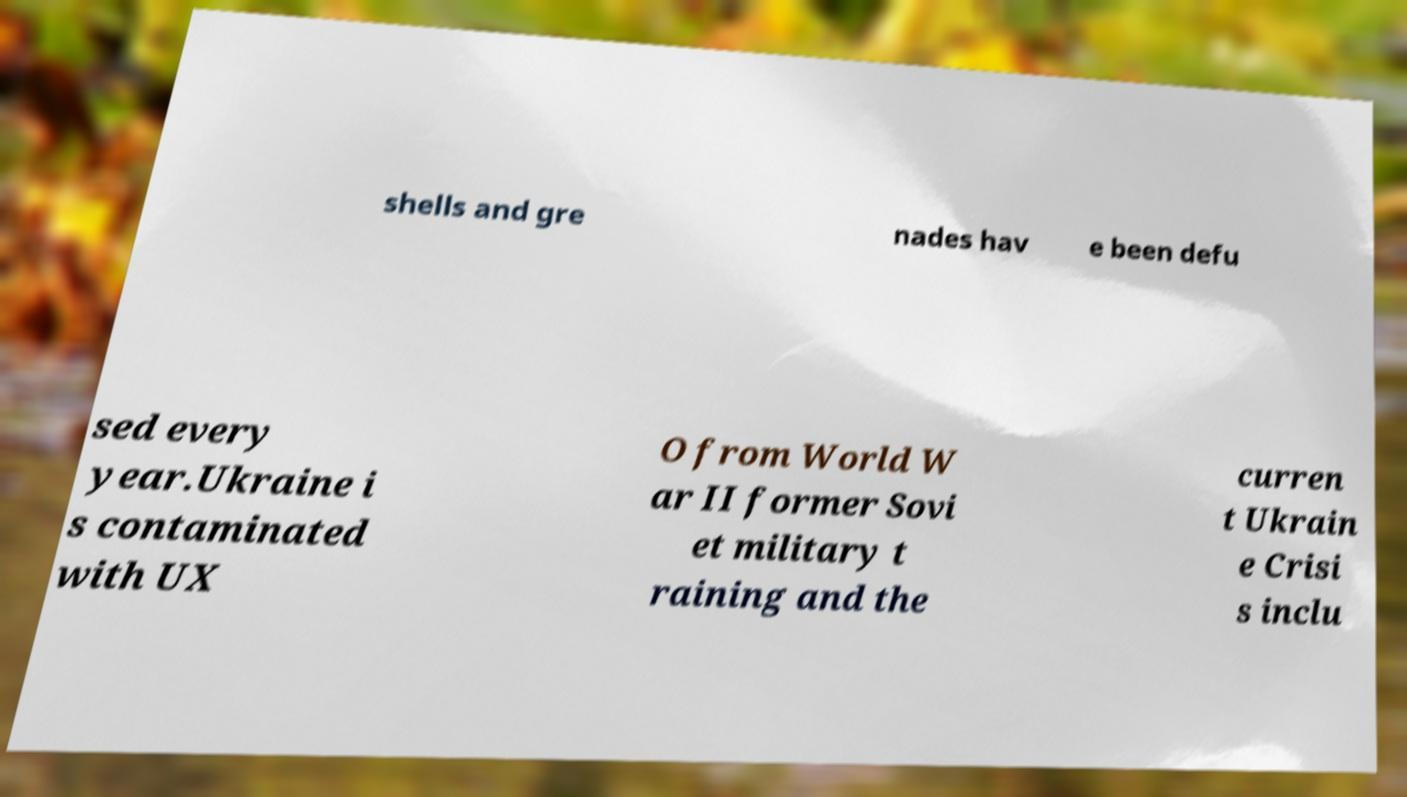Can you accurately transcribe the text from the provided image for me? shells and gre nades hav e been defu sed every year.Ukraine i s contaminated with UX O from World W ar II former Sovi et military t raining and the curren t Ukrain e Crisi s inclu 